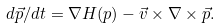Convert formula to latex. <formula><loc_0><loc_0><loc_500><loc_500>d \vec { p } / d t = \nabla H ( p ) - \vec { v } \times \nabla \times \vec { p } .</formula> 